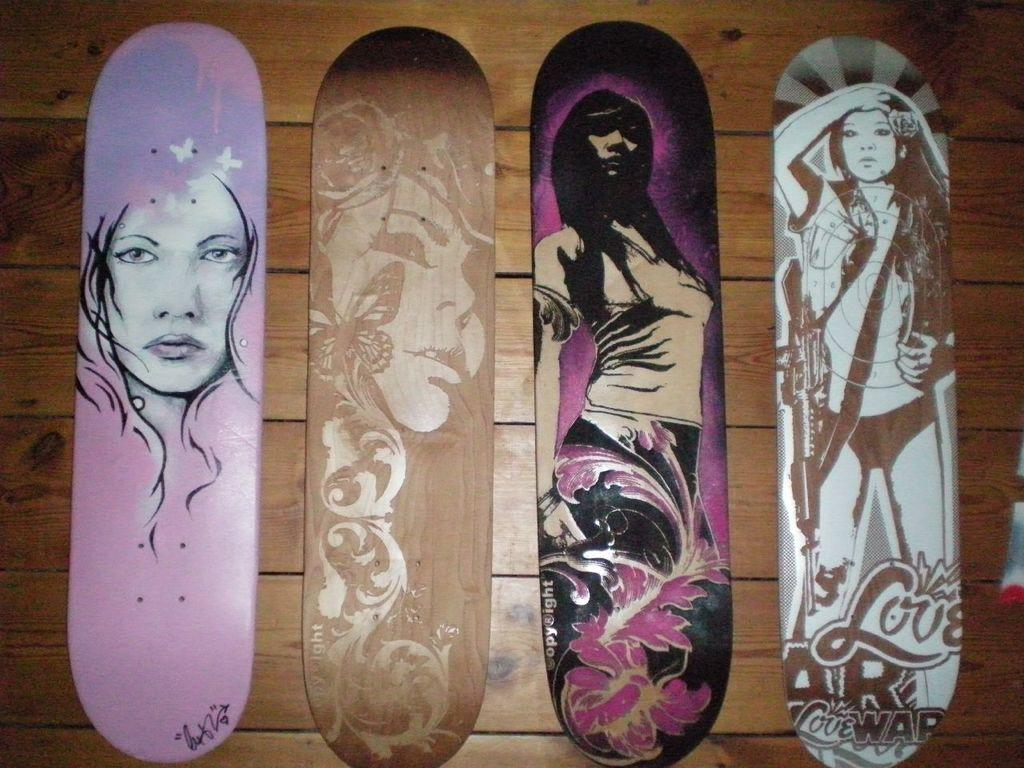How many skateboards are visible in the image? There are four skateboards in the image. Where are the skateboards located? The skateboards are on the floor. What material is the floor made of? The floor is made of wood. What type of watch is visible on the skateboard in the image? There is no watch present on any of the skateboards in the image. 